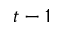<formula> <loc_0><loc_0><loc_500><loc_500>t - 1</formula> 